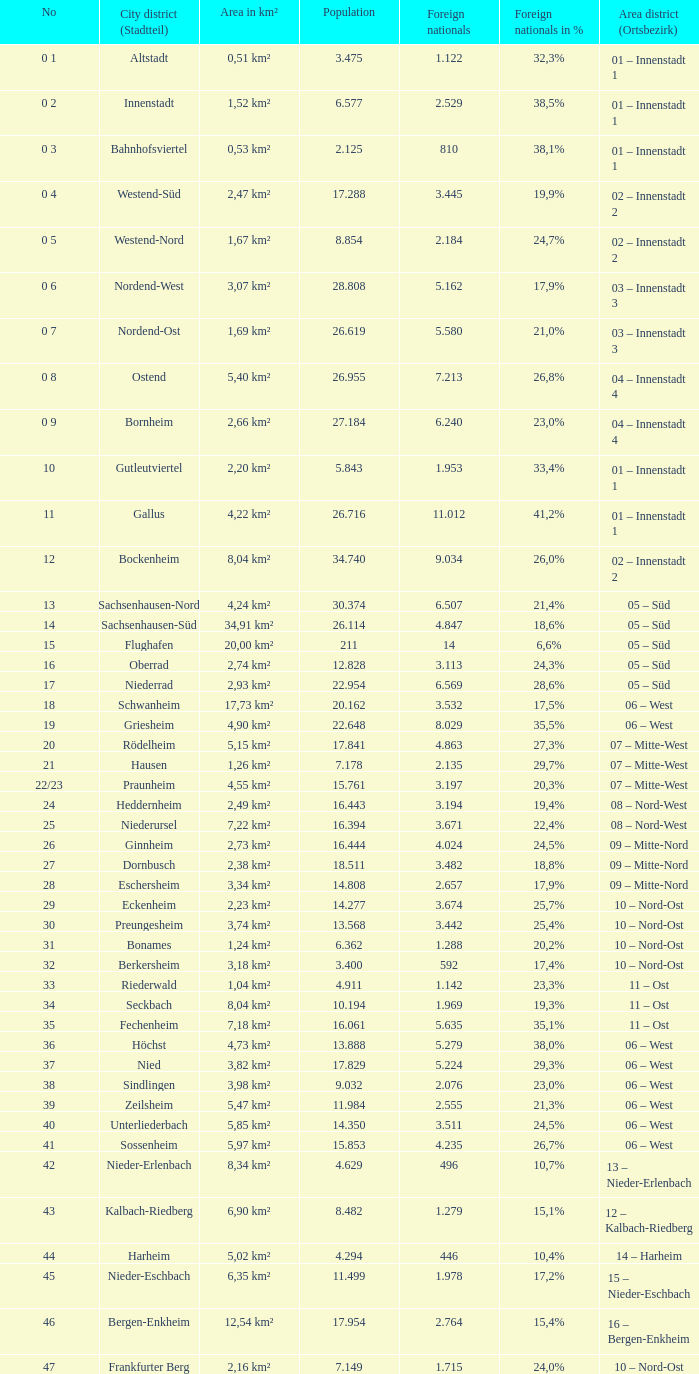Which city district or stadtteil has a foreign population of 5,162? 1.0. 